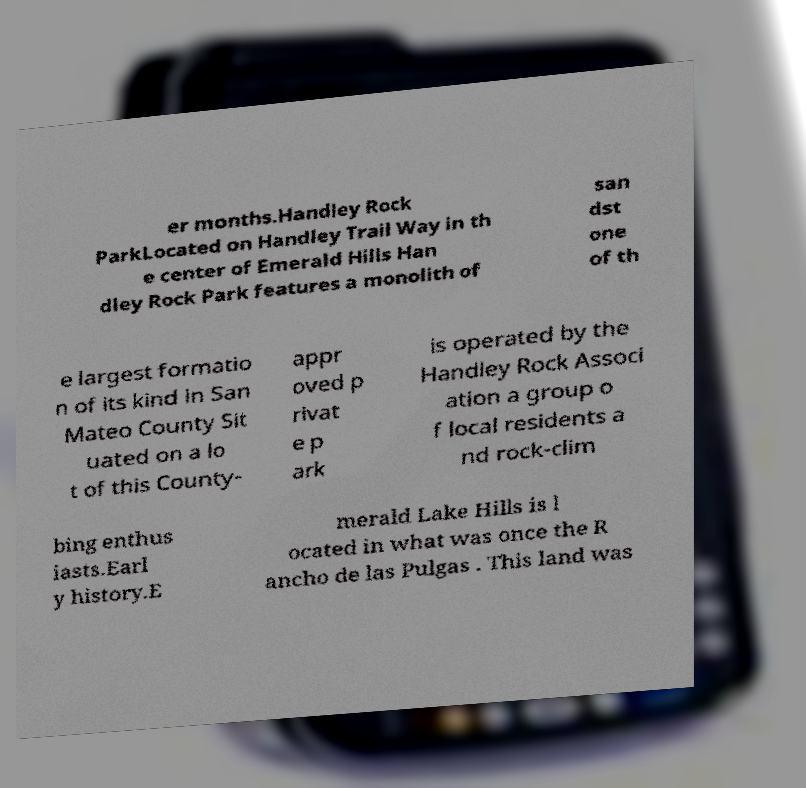I need the written content from this picture converted into text. Can you do that? er months.Handley Rock ParkLocated on Handley Trail Way in th e center of Emerald Hills Han dley Rock Park features a monolith of san dst one of th e largest formatio n of its kind in San Mateo County Sit uated on a lo t of this County- appr oved p rivat e p ark is operated by the Handley Rock Associ ation a group o f local residents a nd rock-clim bing enthus iasts.Earl y history.E merald Lake Hills is l ocated in what was once the R ancho de las Pulgas . This land was 